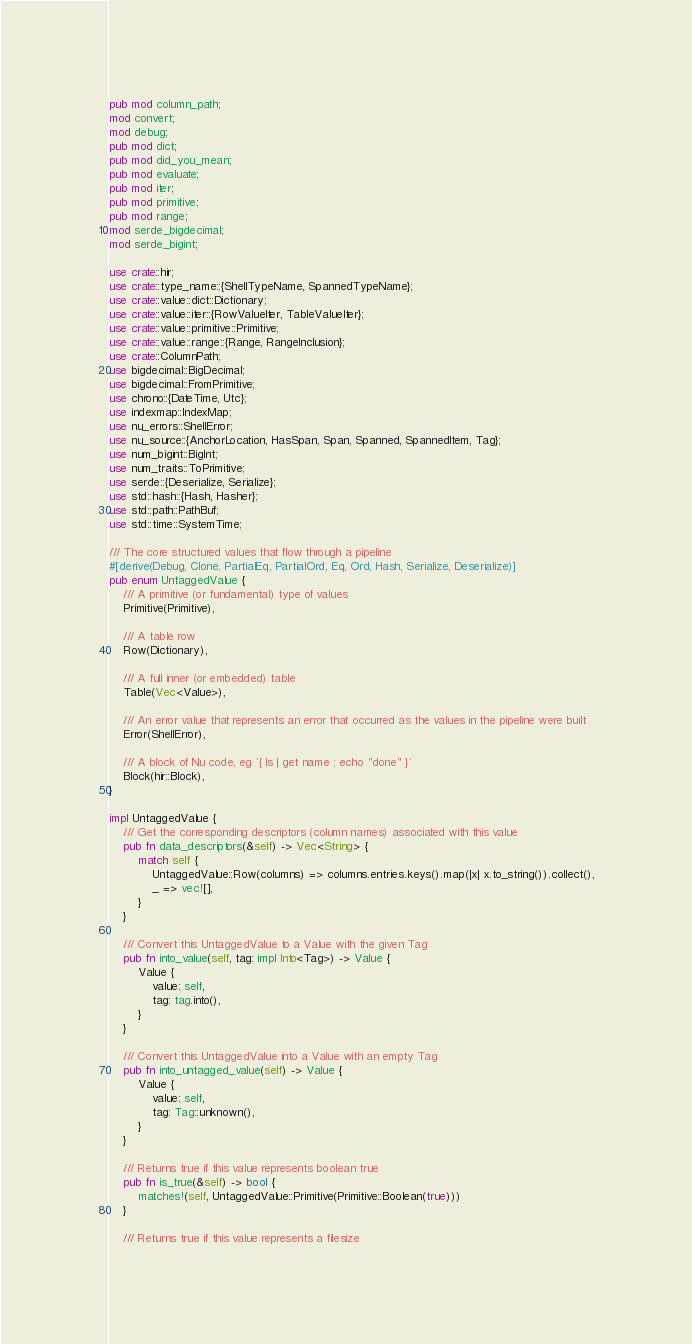Convert code to text. <code><loc_0><loc_0><loc_500><loc_500><_Rust_>pub mod column_path;
mod convert;
mod debug;
pub mod dict;
pub mod did_you_mean;
pub mod evaluate;
pub mod iter;
pub mod primitive;
pub mod range;
mod serde_bigdecimal;
mod serde_bigint;

use crate::hir;
use crate::type_name::{ShellTypeName, SpannedTypeName};
use crate::value::dict::Dictionary;
use crate::value::iter::{RowValueIter, TableValueIter};
use crate::value::primitive::Primitive;
use crate::value::range::{Range, RangeInclusion};
use crate::ColumnPath;
use bigdecimal::BigDecimal;
use bigdecimal::FromPrimitive;
use chrono::{DateTime, Utc};
use indexmap::IndexMap;
use nu_errors::ShellError;
use nu_source::{AnchorLocation, HasSpan, Span, Spanned, SpannedItem, Tag};
use num_bigint::BigInt;
use num_traits::ToPrimitive;
use serde::{Deserialize, Serialize};
use std::hash::{Hash, Hasher};
use std::path::PathBuf;
use std::time::SystemTime;

/// The core structured values that flow through a pipeline
#[derive(Debug, Clone, PartialEq, PartialOrd, Eq, Ord, Hash, Serialize, Deserialize)]
pub enum UntaggedValue {
    /// A primitive (or fundamental) type of values
    Primitive(Primitive),

    /// A table row
    Row(Dictionary),

    /// A full inner (or embedded) table
    Table(Vec<Value>),

    /// An error value that represents an error that occurred as the values in the pipeline were built
    Error(ShellError),

    /// A block of Nu code, eg `{ ls | get name ; echo "done" }`
    Block(hir::Block),
}

impl UntaggedValue {
    /// Get the corresponding descriptors (column names) associated with this value
    pub fn data_descriptors(&self) -> Vec<String> {
        match self {
            UntaggedValue::Row(columns) => columns.entries.keys().map(|x| x.to_string()).collect(),
            _ => vec![],
        }
    }

    /// Convert this UntaggedValue to a Value with the given Tag
    pub fn into_value(self, tag: impl Into<Tag>) -> Value {
        Value {
            value: self,
            tag: tag.into(),
        }
    }

    /// Convert this UntaggedValue into a Value with an empty Tag
    pub fn into_untagged_value(self) -> Value {
        Value {
            value: self,
            tag: Tag::unknown(),
        }
    }

    /// Returns true if this value represents boolean true
    pub fn is_true(&self) -> bool {
        matches!(self, UntaggedValue::Primitive(Primitive::Boolean(true)))
    }

    /// Returns true if this value represents a filesize</code> 